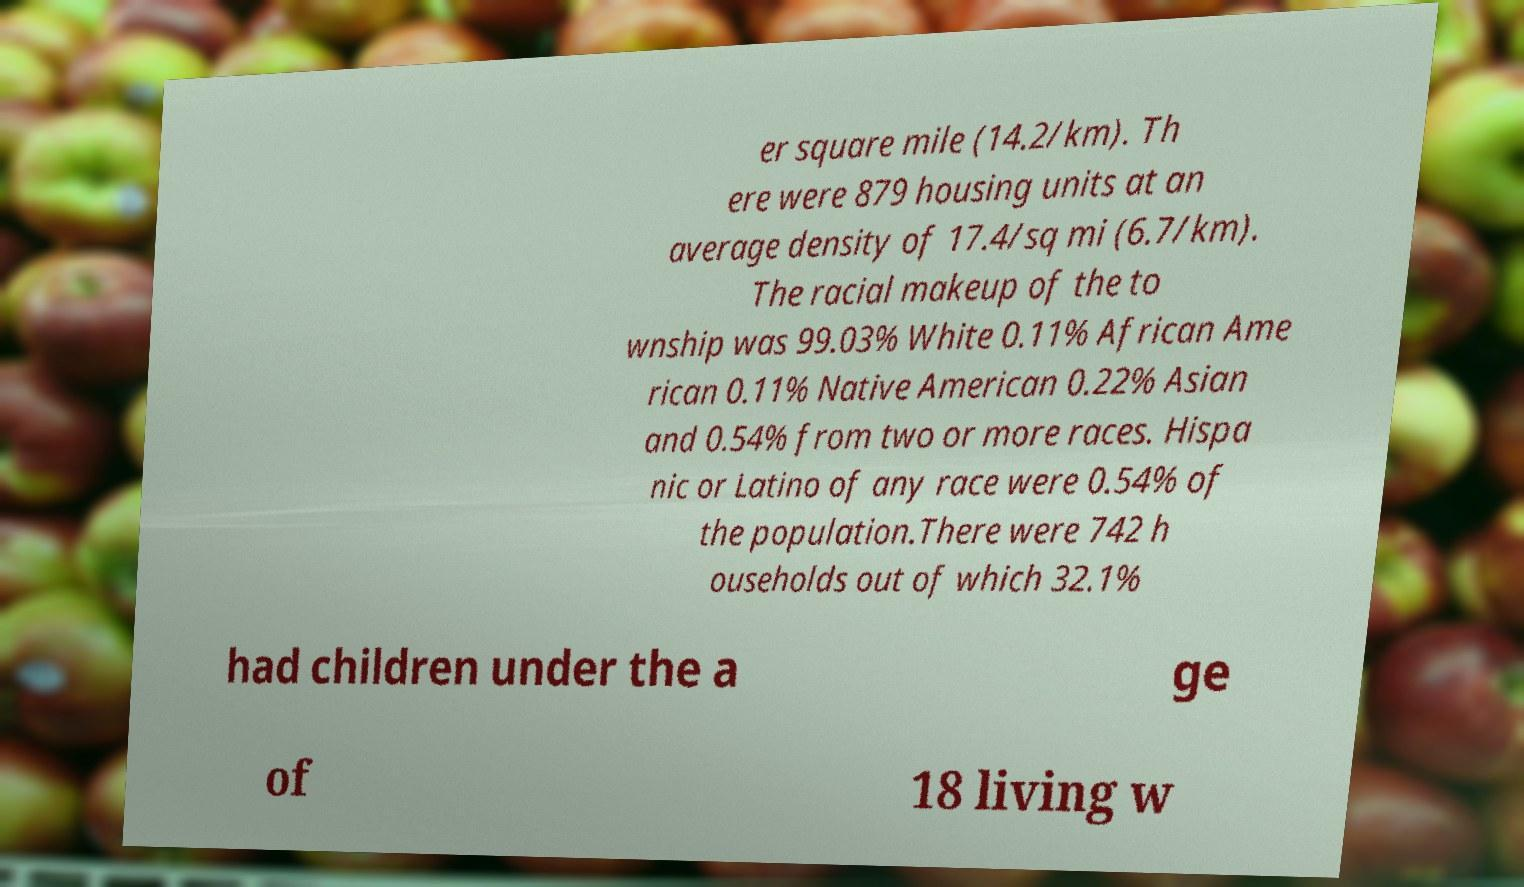Could you assist in decoding the text presented in this image and type it out clearly? er square mile (14.2/km). Th ere were 879 housing units at an average density of 17.4/sq mi (6.7/km). The racial makeup of the to wnship was 99.03% White 0.11% African Ame rican 0.11% Native American 0.22% Asian and 0.54% from two or more races. Hispa nic or Latino of any race were 0.54% of the population.There were 742 h ouseholds out of which 32.1% had children under the a ge of 18 living w 